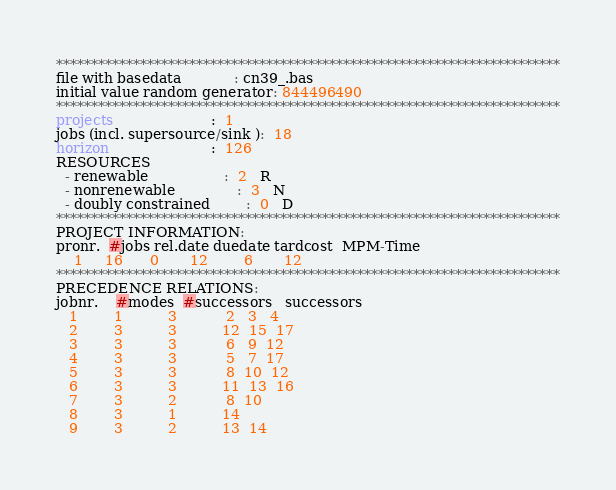<code> <loc_0><loc_0><loc_500><loc_500><_ObjectiveC_>************************************************************************
file with basedata            : cn39_.bas
initial value random generator: 844496490
************************************************************************
projects                      :  1
jobs (incl. supersource/sink ):  18
horizon                       :  126
RESOURCES
  - renewable                 :  2   R
  - nonrenewable              :  3   N
  - doubly constrained        :  0   D
************************************************************************
PROJECT INFORMATION:
pronr.  #jobs rel.date duedate tardcost  MPM-Time
    1     16      0       12        6       12
************************************************************************
PRECEDENCE RELATIONS:
jobnr.    #modes  #successors   successors
   1        1          3           2   3   4
   2        3          3          12  15  17
   3        3          3           6   9  12
   4        3          3           5   7  17
   5        3          3           8  10  12
   6        3          3          11  13  16
   7        3          2           8  10
   8        3          1          14
   9        3          2          13  14</code> 